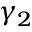Convert formula to latex. <formula><loc_0><loc_0><loc_500><loc_500>\gamma _ { 2 }</formula> 